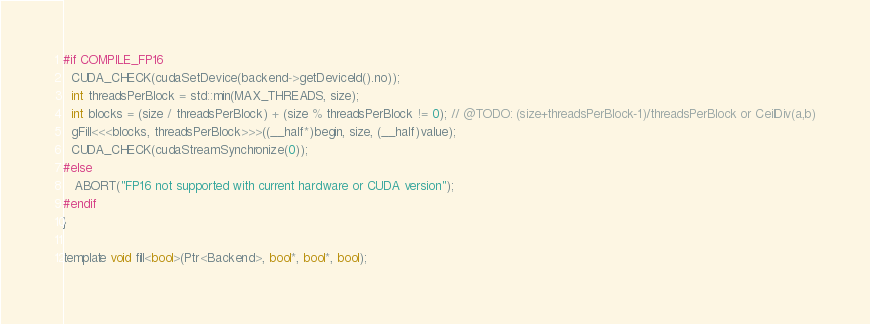Convert code to text. <code><loc_0><loc_0><loc_500><loc_500><_Cuda_>#if COMPILE_FP16
  CUDA_CHECK(cudaSetDevice(backend->getDeviceId().no));
  int threadsPerBlock = std::min(MAX_THREADS, size);
  int blocks = (size / threadsPerBlock) + (size % threadsPerBlock != 0); // @TODO: (size+threadsPerBlock-1)/threadsPerBlock or CeilDiv(a,b)
  gFill<<<blocks, threadsPerBlock>>>((__half*)begin, size, (__half)value);
  CUDA_CHECK(cudaStreamSynchronize(0));
#else
   ABORT("FP16 not supported with current hardware or CUDA version");
#endif
}

template void fill<bool>(Ptr<Backend>, bool*, bool*, bool);</code> 